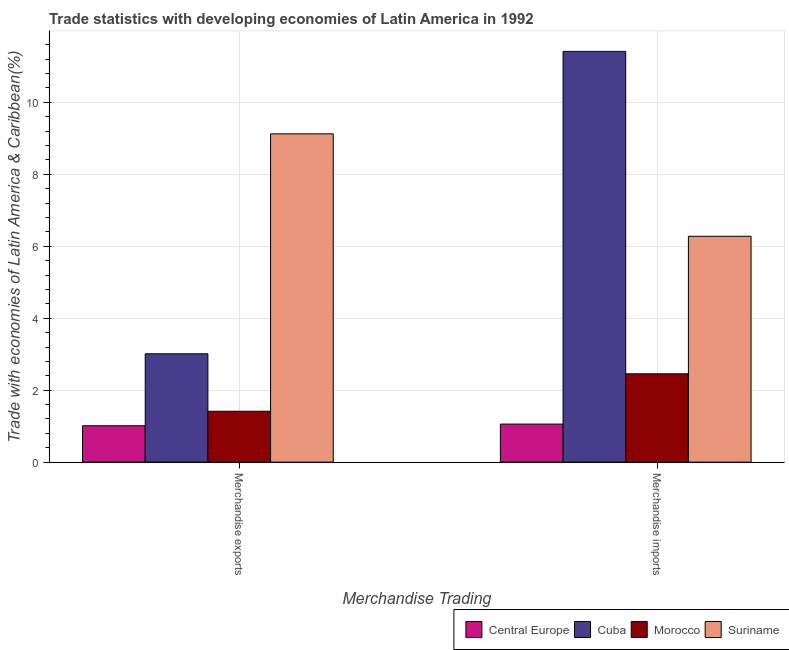Are the number of bars per tick equal to the number of legend labels?
Offer a very short reply. Yes. How many bars are there on the 1st tick from the left?
Ensure brevity in your answer.  4. How many bars are there on the 1st tick from the right?
Your response must be concise. 4. What is the label of the 2nd group of bars from the left?
Offer a terse response. Merchandise imports. What is the merchandise exports in Suriname?
Offer a very short reply. 9.12. Across all countries, what is the maximum merchandise exports?
Provide a succinct answer. 9.12. Across all countries, what is the minimum merchandise exports?
Provide a succinct answer. 1.01. In which country was the merchandise imports maximum?
Give a very brief answer. Cuba. In which country was the merchandise exports minimum?
Your answer should be compact. Central Europe. What is the total merchandise exports in the graph?
Ensure brevity in your answer.  14.56. What is the difference between the merchandise exports in Central Europe and that in Morocco?
Offer a terse response. -0.4. What is the difference between the merchandise exports in Central Europe and the merchandise imports in Cuba?
Your answer should be compact. -10.41. What is the average merchandise exports per country?
Your answer should be compact. 3.64. What is the difference between the merchandise exports and merchandise imports in Suriname?
Provide a succinct answer. 2.85. In how many countries, is the merchandise exports greater than 5.6 %?
Your answer should be very brief. 1. What is the ratio of the merchandise exports in Morocco to that in Central Europe?
Offer a very short reply. 1.4. Is the merchandise imports in Morocco less than that in Suriname?
Your answer should be compact. Yes. In how many countries, is the merchandise exports greater than the average merchandise exports taken over all countries?
Make the answer very short. 1. What does the 1st bar from the left in Merchandise imports represents?
Make the answer very short. Central Europe. What does the 3rd bar from the right in Merchandise imports represents?
Keep it short and to the point. Cuba. Are all the bars in the graph horizontal?
Your response must be concise. No. Are the values on the major ticks of Y-axis written in scientific E-notation?
Your answer should be very brief. No. Does the graph contain grids?
Offer a very short reply. Yes. How are the legend labels stacked?
Offer a very short reply. Horizontal. What is the title of the graph?
Offer a very short reply. Trade statistics with developing economies of Latin America in 1992. Does "American Samoa" appear as one of the legend labels in the graph?
Offer a very short reply. No. What is the label or title of the X-axis?
Give a very brief answer. Merchandise Trading. What is the label or title of the Y-axis?
Provide a short and direct response. Trade with economies of Latin America & Caribbean(%). What is the Trade with economies of Latin America & Caribbean(%) in Central Europe in Merchandise exports?
Your response must be concise. 1.01. What is the Trade with economies of Latin America & Caribbean(%) in Cuba in Merchandise exports?
Provide a succinct answer. 3.01. What is the Trade with economies of Latin America & Caribbean(%) of Morocco in Merchandise exports?
Your answer should be very brief. 1.41. What is the Trade with economies of Latin America & Caribbean(%) of Suriname in Merchandise exports?
Your response must be concise. 9.12. What is the Trade with economies of Latin America & Caribbean(%) in Central Europe in Merchandise imports?
Provide a short and direct response. 1.06. What is the Trade with economies of Latin America & Caribbean(%) of Cuba in Merchandise imports?
Your response must be concise. 11.42. What is the Trade with economies of Latin America & Caribbean(%) in Morocco in Merchandise imports?
Ensure brevity in your answer.  2.45. What is the Trade with economies of Latin America & Caribbean(%) of Suriname in Merchandise imports?
Give a very brief answer. 6.28. Across all Merchandise Trading, what is the maximum Trade with economies of Latin America & Caribbean(%) in Central Europe?
Offer a very short reply. 1.06. Across all Merchandise Trading, what is the maximum Trade with economies of Latin America & Caribbean(%) in Cuba?
Ensure brevity in your answer.  11.42. Across all Merchandise Trading, what is the maximum Trade with economies of Latin America & Caribbean(%) of Morocco?
Provide a succinct answer. 2.45. Across all Merchandise Trading, what is the maximum Trade with economies of Latin America & Caribbean(%) in Suriname?
Offer a very short reply. 9.12. Across all Merchandise Trading, what is the minimum Trade with economies of Latin America & Caribbean(%) in Central Europe?
Make the answer very short. 1.01. Across all Merchandise Trading, what is the minimum Trade with economies of Latin America & Caribbean(%) in Cuba?
Offer a very short reply. 3.01. Across all Merchandise Trading, what is the minimum Trade with economies of Latin America & Caribbean(%) in Morocco?
Offer a terse response. 1.41. Across all Merchandise Trading, what is the minimum Trade with economies of Latin America & Caribbean(%) of Suriname?
Your response must be concise. 6.28. What is the total Trade with economies of Latin America & Caribbean(%) of Central Europe in the graph?
Offer a terse response. 2.07. What is the total Trade with economies of Latin America & Caribbean(%) in Cuba in the graph?
Offer a terse response. 14.43. What is the total Trade with economies of Latin America & Caribbean(%) in Morocco in the graph?
Provide a short and direct response. 3.87. What is the total Trade with economies of Latin America & Caribbean(%) of Suriname in the graph?
Ensure brevity in your answer.  15.4. What is the difference between the Trade with economies of Latin America & Caribbean(%) of Central Europe in Merchandise exports and that in Merchandise imports?
Make the answer very short. -0.05. What is the difference between the Trade with economies of Latin America & Caribbean(%) of Cuba in Merchandise exports and that in Merchandise imports?
Your answer should be compact. -8.41. What is the difference between the Trade with economies of Latin America & Caribbean(%) in Morocco in Merchandise exports and that in Merchandise imports?
Make the answer very short. -1.04. What is the difference between the Trade with economies of Latin America & Caribbean(%) of Suriname in Merchandise exports and that in Merchandise imports?
Offer a terse response. 2.85. What is the difference between the Trade with economies of Latin America & Caribbean(%) in Central Europe in Merchandise exports and the Trade with economies of Latin America & Caribbean(%) in Cuba in Merchandise imports?
Provide a succinct answer. -10.41. What is the difference between the Trade with economies of Latin America & Caribbean(%) of Central Europe in Merchandise exports and the Trade with economies of Latin America & Caribbean(%) of Morocco in Merchandise imports?
Keep it short and to the point. -1.44. What is the difference between the Trade with economies of Latin America & Caribbean(%) of Central Europe in Merchandise exports and the Trade with economies of Latin America & Caribbean(%) of Suriname in Merchandise imports?
Your answer should be very brief. -5.27. What is the difference between the Trade with economies of Latin America & Caribbean(%) of Cuba in Merchandise exports and the Trade with economies of Latin America & Caribbean(%) of Morocco in Merchandise imports?
Your answer should be compact. 0.56. What is the difference between the Trade with economies of Latin America & Caribbean(%) of Cuba in Merchandise exports and the Trade with economies of Latin America & Caribbean(%) of Suriname in Merchandise imports?
Provide a succinct answer. -3.27. What is the difference between the Trade with economies of Latin America & Caribbean(%) in Morocco in Merchandise exports and the Trade with economies of Latin America & Caribbean(%) in Suriname in Merchandise imports?
Ensure brevity in your answer.  -4.86. What is the average Trade with economies of Latin America & Caribbean(%) in Central Europe per Merchandise Trading?
Give a very brief answer. 1.03. What is the average Trade with economies of Latin America & Caribbean(%) of Cuba per Merchandise Trading?
Provide a short and direct response. 7.21. What is the average Trade with economies of Latin America & Caribbean(%) of Morocco per Merchandise Trading?
Your answer should be compact. 1.93. What is the average Trade with economies of Latin America & Caribbean(%) of Suriname per Merchandise Trading?
Offer a terse response. 7.7. What is the difference between the Trade with economies of Latin America & Caribbean(%) of Central Europe and Trade with economies of Latin America & Caribbean(%) of Cuba in Merchandise exports?
Keep it short and to the point. -2. What is the difference between the Trade with economies of Latin America & Caribbean(%) in Central Europe and Trade with economies of Latin America & Caribbean(%) in Morocco in Merchandise exports?
Ensure brevity in your answer.  -0.4. What is the difference between the Trade with economies of Latin America & Caribbean(%) of Central Europe and Trade with economies of Latin America & Caribbean(%) of Suriname in Merchandise exports?
Ensure brevity in your answer.  -8.11. What is the difference between the Trade with economies of Latin America & Caribbean(%) in Cuba and Trade with economies of Latin America & Caribbean(%) in Morocco in Merchandise exports?
Provide a short and direct response. 1.6. What is the difference between the Trade with economies of Latin America & Caribbean(%) of Cuba and Trade with economies of Latin America & Caribbean(%) of Suriname in Merchandise exports?
Make the answer very short. -6.11. What is the difference between the Trade with economies of Latin America & Caribbean(%) of Morocco and Trade with economies of Latin America & Caribbean(%) of Suriname in Merchandise exports?
Offer a very short reply. -7.71. What is the difference between the Trade with economies of Latin America & Caribbean(%) in Central Europe and Trade with economies of Latin America & Caribbean(%) in Cuba in Merchandise imports?
Make the answer very short. -10.36. What is the difference between the Trade with economies of Latin America & Caribbean(%) of Central Europe and Trade with economies of Latin America & Caribbean(%) of Morocco in Merchandise imports?
Your answer should be very brief. -1.4. What is the difference between the Trade with economies of Latin America & Caribbean(%) in Central Europe and Trade with economies of Latin America & Caribbean(%) in Suriname in Merchandise imports?
Offer a very short reply. -5.22. What is the difference between the Trade with economies of Latin America & Caribbean(%) in Cuba and Trade with economies of Latin America & Caribbean(%) in Morocco in Merchandise imports?
Provide a succinct answer. 8.96. What is the difference between the Trade with economies of Latin America & Caribbean(%) of Cuba and Trade with economies of Latin America & Caribbean(%) of Suriname in Merchandise imports?
Provide a short and direct response. 5.14. What is the difference between the Trade with economies of Latin America & Caribbean(%) in Morocco and Trade with economies of Latin America & Caribbean(%) in Suriname in Merchandise imports?
Your answer should be very brief. -3.82. What is the ratio of the Trade with economies of Latin America & Caribbean(%) of Central Europe in Merchandise exports to that in Merchandise imports?
Your response must be concise. 0.96. What is the ratio of the Trade with economies of Latin America & Caribbean(%) of Cuba in Merchandise exports to that in Merchandise imports?
Keep it short and to the point. 0.26. What is the ratio of the Trade with economies of Latin America & Caribbean(%) in Morocco in Merchandise exports to that in Merchandise imports?
Your answer should be compact. 0.58. What is the ratio of the Trade with economies of Latin America & Caribbean(%) in Suriname in Merchandise exports to that in Merchandise imports?
Keep it short and to the point. 1.45. What is the difference between the highest and the second highest Trade with economies of Latin America & Caribbean(%) of Central Europe?
Provide a succinct answer. 0.05. What is the difference between the highest and the second highest Trade with economies of Latin America & Caribbean(%) in Cuba?
Give a very brief answer. 8.41. What is the difference between the highest and the second highest Trade with economies of Latin America & Caribbean(%) of Morocco?
Give a very brief answer. 1.04. What is the difference between the highest and the second highest Trade with economies of Latin America & Caribbean(%) of Suriname?
Ensure brevity in your answer.  2.85. What is the difference between the highest and the lowest Trade with economies of Latin America & Caribbean(%) of Central Europe?
Your answer should be very brief. 0.05. What is the difference between the highest and the lowest Trade with economies of Latin America & Caribbean(%) in Cuba?
Provide a succinct answer. 8.41. What is the difference between the highest and the lowest Trade with economies of Latin America & Caribbean(%) of Morocco?
Offer a terse response. 1.04. What is the difference between the highest and the lowest Trade with economies of Latin America & Caribbean(%) in Suriname?
Give a very brief answer. 2.85. 